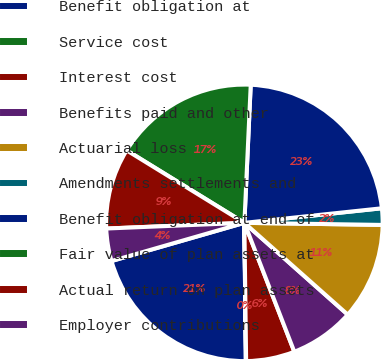<chart> <loc_0><loc_0><loc_500><loc_500><pie_chart><fcel>Benefit obligation at<fcel>Service cost<fcel>Interest cost<fcel>Benefits paid and other<fcel>Actuarial loss<fcel>Amendments settlements and<fcel>Benefit obligation at end of<fcel>Fair value of plan assets at<fcel>Actual return on plan assets<fcel>Employer contributions<nl><fcel>20.71%<fcel>0.04%<fcel>5.68%<fcel>7.56%<fcel>11.32%<fcel>1.92%<fcel>22.59%<fcel>16.95%<fcel>9.44%<fcel>3.8%<nl></chart> 